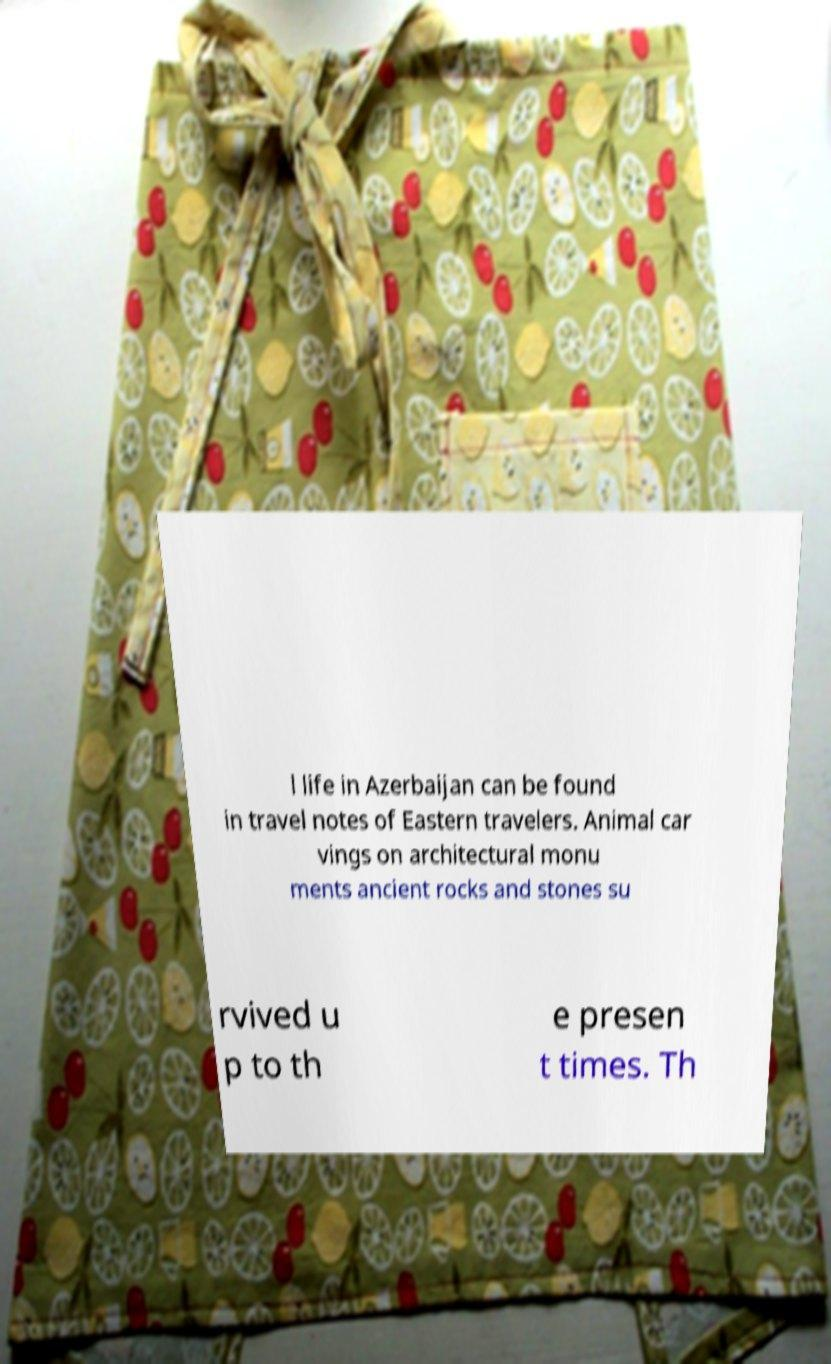Please read and relay the text visible in this image. What does it say? l life in Azerbaijan can be found in travel notes of Eastern travelers. Animal car vings on architectural monu ments ancient rocks and stones su rvived u p to th e presen t times. Th 